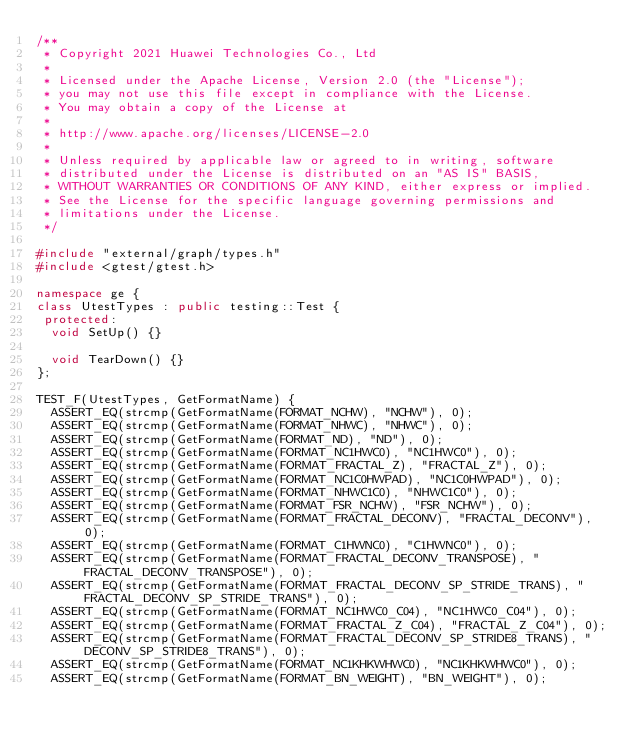Convert code to text. <code><loc_0><loc_0><loc_500><loc_500><_C++_>/**
 * Copyright 2021 Huawei Technologies Co., Ltd
 *
 * Licensed under the Apache License, Version 2.0 (the "License");
 * you may not use this file except in compliance with the License.
 * You may obtain a copy of the License at
 *
 * http://www.apache.org/licenses/LICENSE-2.0
 *
 * Unless required by applicable law or agreed to in writing, software
 * distributed under the License is distributed on an "AS IS" BASIS,
 * WITHOUT WARRANTIES OR CONDITIONS OF ANY KIND, either express or implied.
 * See the License for the specific language governing permissions and
 * limitations under the License.
 */

#include "external/graph/types.h"
#include <gtest/gtest.h>

namespace ge {
class UtestTypes : public testing::Test {
 protected:
  void SetUp() {}

  void TearDown() {}
};

TEST_F(UtestTypes, GetFormatName) {
  ASSERT_EQ(strcmp(GetFormatName(FORMAT_NCHW), "NCHW"), 0);
  ASSERT_EQ(strcmp(GetFormatName(FORMAT_NHWC), "NHWC"), 0);
  ASSERT_EQ(strcmp(GetFormatName(FORMAT_ND), "ND"), 0);
  ASSERT_EQ(strcmp(GetFormatName(FORMAT_NC1HWC0), "NC1HWC0"), 0);
  ASSERT_EQ(strcmp(GetFormatName(FORMAT_FRACTAL_Z), "FRACTAL_Z"), 0);
  ASSERT_EQ(strcmp(GetFormatName(FORMAT_NC1C0HWPAD), "NC1C0HWPAD"), 0);
  ASSERT_EQ(strcmp(GetFormatName(FORMAT_NHWC1C0), "NHWC1C0"), 0);
  ASSERT_EQ(strcmp(GetFormatName(FORMAT_FSR_NCHW), "FSR_NCHW"), 0);
  ASSERT_EQ(strcmp(GetFormatName(FORMAT_FRACTAL_DECONV), "FRACTAL_DECONV"), 0);
  ASSERT_EQ(strcmp(GetFormatName(FORMAT_C1HWNC0), "C1HWNC0"), 0);
  ASSERT_EQ(strcmp(GetFormatName(FORMAT_FRACTAL_DECONV_TRANSPOSE), "FRACTAL_DECONV_TRANSPOSE"), 0);
  ASSERT_EQ(strcmp(GetFormatName(FORMAT_FRACTAL_DECONV_SP_STRIDE_TRANS), "FRACTAL_DECONV_SP_STRIDE_TRANS"), 0);
  ASSERT_EQ(strcmp(GetFormatName(FORMAT_NC1HWC0_C04), "NC1HWC0_C04"), 0);
  ASSERT_EQ(strcmp(GetFormatName(FORMAT_FRACTAL_Z_C04), "FRACTAL_Z_C04"), 0);
  ASSERT_EQ(strcmp(GetFormatName(FORMAT_FRACTAL_DECONV_SP_STRIDE8_TRANS), "DECONV_SP_STRIDE8_TRANS"), 0);
  ASSERT_EQ(strcmp(GetFormatName(FORMAT_NC1KHKWHWC0), "NC1KHKWHWC0"), 0);
  ASSERT_EQ(strcmp(GetFormatName(FORMAT_BN_WEIGHT), "BN_WEIGHT"), 0);</code> 